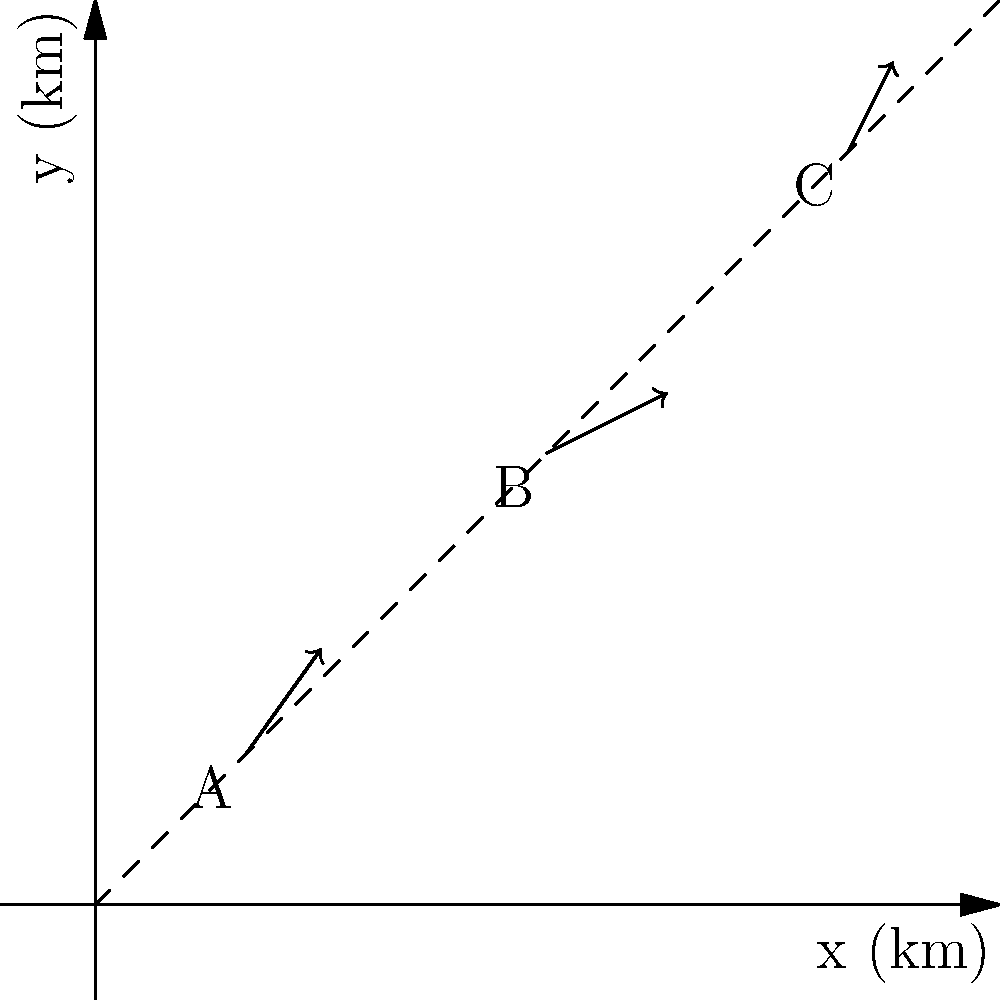The diagram shows ocean current vectors at three locations (A, B, and C) in a potential wave energy converter (WEC) deployment area. The x and y axes represent distances in kilometers. The dashed line represents the optimal placement line for WECs. Which location would be best for placing a WEC to maximize energy output, and what is the magnitude of the ocean current vector at that location? To solve this problem, we need to follow these steps:

1. Identify the ocean current vectors for each location:
   A: $\vec{v_A} = (0.5, 0.7)$
   B: $\vec{v_B} = (0.8, 0.4)$
   C: $\vec{v_C} = (0.3, 0.6)$

2. Calculate the magnitude of each vector using the formula: $|\vec{v}| = \sqrt{x^2 + y^2}$
   A: $|\vec{v_A}| = \sqrt{0.5^2 + 0.7^2} = \sqrt{0.25 + 0.49} = \sqrt{0.74} \approx 0.86$
   B: $|\vec{v_B}| = \sqrt{0.8^2 + 0.4^2} = \sqrt{0.64 + 0.16} = \sqrt{0.80} \approx 0.89$
   C: $|\vec{v_C}| = \sqrt{0.3^2 + 0.6^2} = \sqrt{0.09 + 0.36} = \sqrt{0.45} \approx 0.67$

3. Compare the magnitudes:
   B has the largest magnitude (0.89), followed by A (0.86), then C (0.67).

4. Consider the optimal placement line:
   The dashed line represents the optimal placement for WECs. Point B is closest to this line.

5. Conclusion:
   Location B is the best for placing a WEC because it has the largest current magnitude and is closest to the optimal placement line.
Answer: Location B, magnitude 0.89 